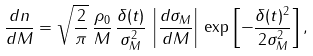<formula> <loc_0><loc_0><loc_500><loc_500>\frac { d n } { d M } = \sqrt { \frac { 2 } { \pi } } \, \frac { \rho _ { 0 } } { M } \, \frac { \delta ( t ) } { \sigma _ { M } ^ { 2 } } \, \left | \frac { d \sigma _ { M } } { d M } \right | \, \exp \left [ - \frac { \delta ( t ) ^ { 2 } } { 2 \sigma _ { M } ^ { 2 } } \right ] ,</formula> 